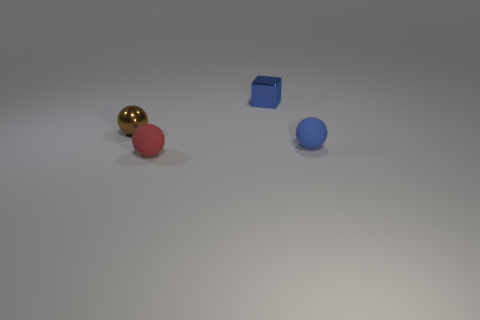Add 3 big rubber cylinders. How many objects exist? 7 Subtract all balls. How many objects are left? 1 Subtract all big gray matte cubes. Subtract all rubber objects. How many objects are left? 2 Add 4 small metal blocks. How many small metal blocks are left? 5 Add 4 red matte balls. How many red matte balls exist? 5 Subtract 0 green cylinders. How many objects are left? 4 